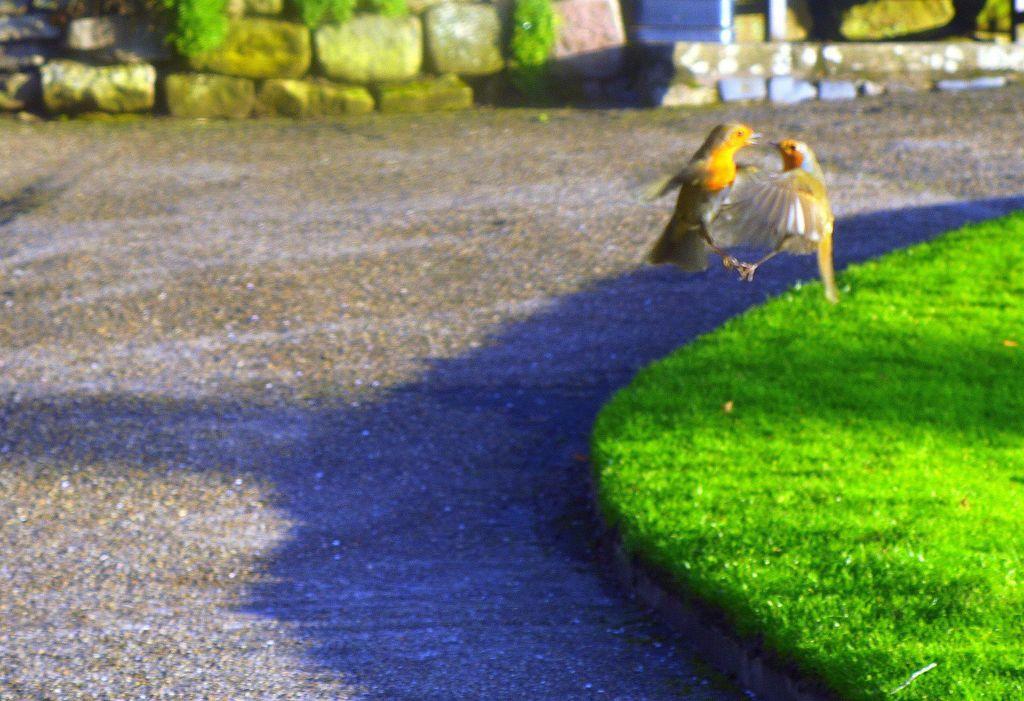Please provide a concise description of this image. In this image, we can see two birds are flying in the air. At the bottom, there is a road and grass. Top of the image, we can see stones. 